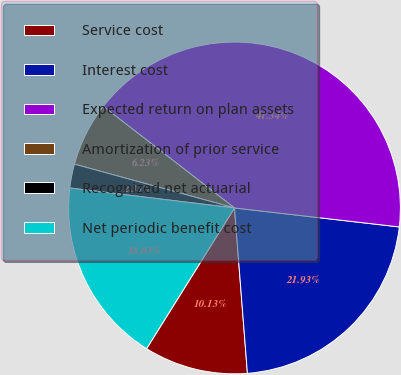<chart> <loc_0><loc_0><loc_500><loc_500><pie_chart><fcel>Service cost<fcel>Interest cost<fcel>Expected return on plan assets<fcel>Amortization of prior service<fcel>Recognized net actuarial<fcel>Net periodic benefit cost<nl><fcel>10.13%<fcel>21.93%<fcel>41.34%<fcel>6.23%<fcel>2.33%<fcel>18.03%<nl></chart> 